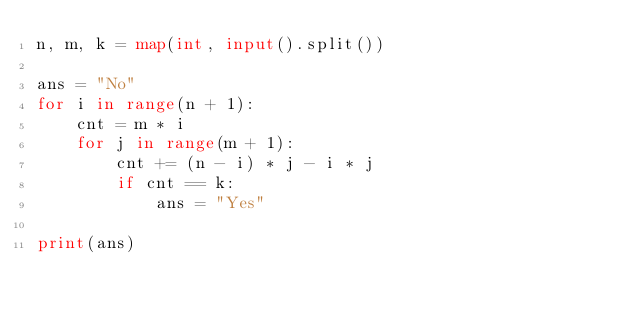<code> <loc_0><loc_0><loc_500><loc_500><_Python_>n, m, k = map(int, input().split())

ans = "No"
for i in range(n + 1):
    cnt = m * i
    for j in range(m + 1):
        cnt += (n - i) * j - i * j
        if cnt == k:
            ans = "Yes"

print(ans)
</code> 